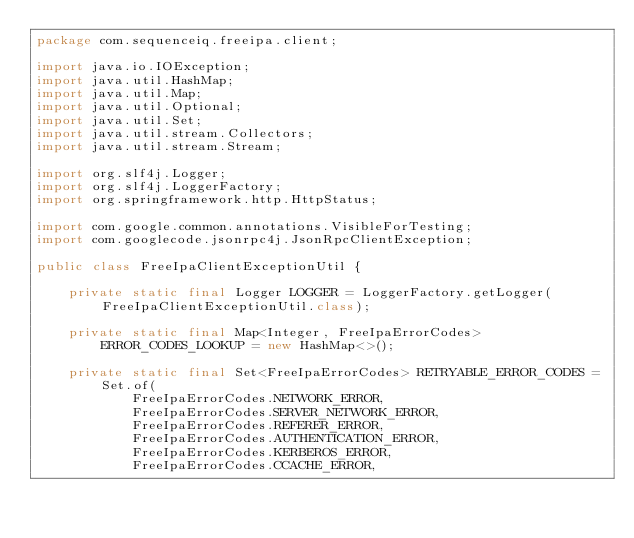Convert code to text. <code><loc_0><loc_0><loc_500><loc_500><_Java_>package com.sequenceiq.freeipa.client;

import java.io.IOException;
import java.util.HashMap;
import java.util.Map;
import java.util.Optional;
import java.util.Set;
import java.util.stream.Collectors;
import java.util.stream.Stream;

import org.slf4j.Logger;
import org.slf4j.LoggerFactory;
import org.springframework.http.HttpStatus;

import com.google.common.annotations.VisibleForTesting;
import com.googlecode.jsonrpc4j.JsonRpcClientException;

public class FreeIpaClientExceptionUtil {

    private static final Logger LOGGER = LoggerFactory.getLogger(FreeIpaClientExceptionUtil.class);

    private static final Map<Integer, FreeIpaErrorCodes> ERROR_CODES_LOOKUP = new HashMap<>();

    private static final Set<FreeIpaErrorCodes> RETRYABLE_ERROR_CODES = Set.of(
            FreeIpaErrorCodes.NETWORK_ERROR,
            FreeIpaErrorCodes.SERVER_NETWORK_ERROR,
            FreeIpaErrorCodes.REFERER_ERROR,
            FreeIpaErrorCodes.AUTHENTICATION_ERROR,
            FreeIpaErrorCodes.KERBEROS_ERROR,
            FreeIpaErrorCodes.CCACHE_ERROR,</code> 